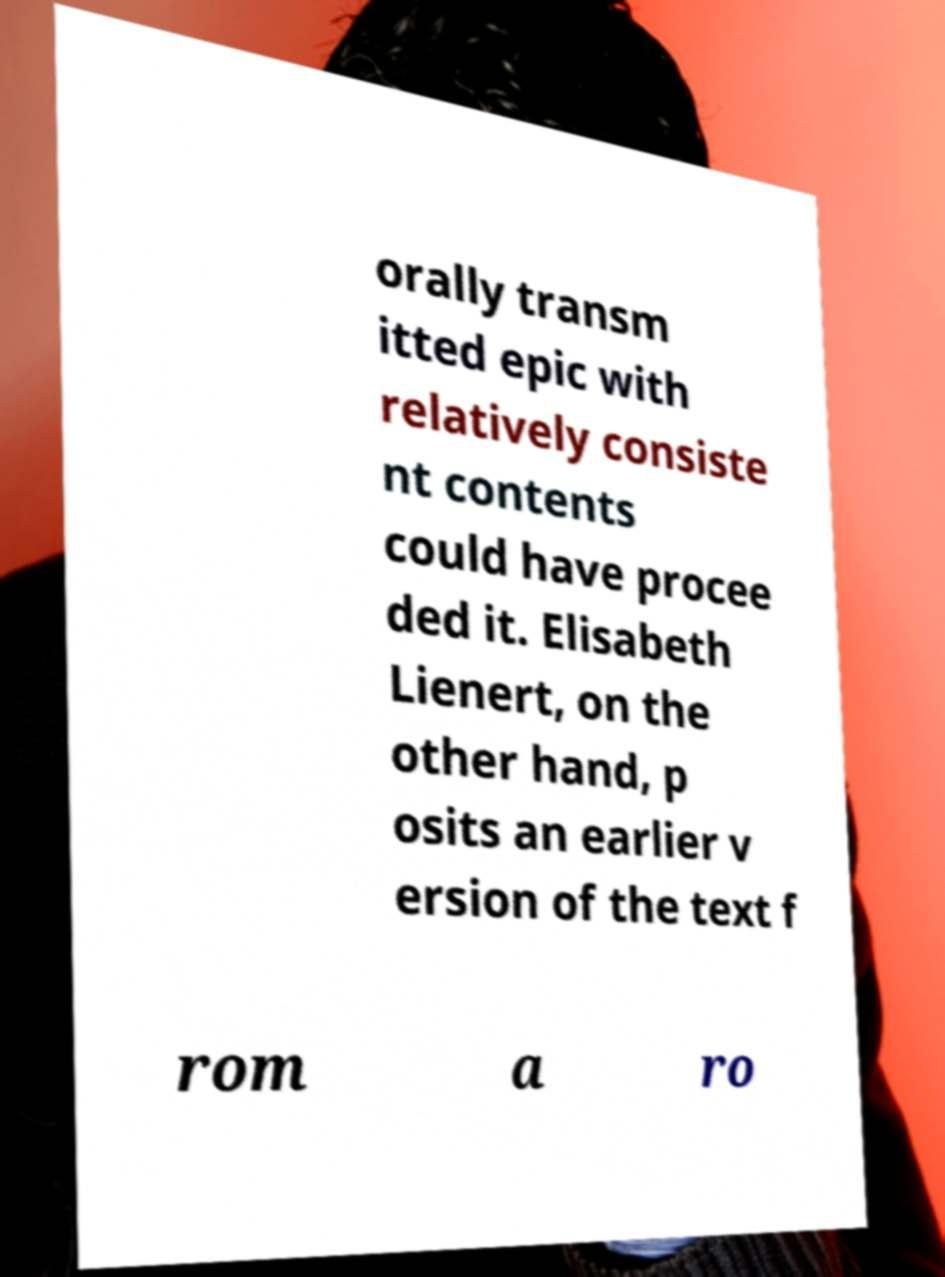What messages or text are displayed in this image? I need them in a readable, typed format. orally transm itted epic with relatively consiste nt contents could have procee ded it. Elisabeth Lienert, on the other hand, p osits an earlier v ersion of the text f rom a ro 